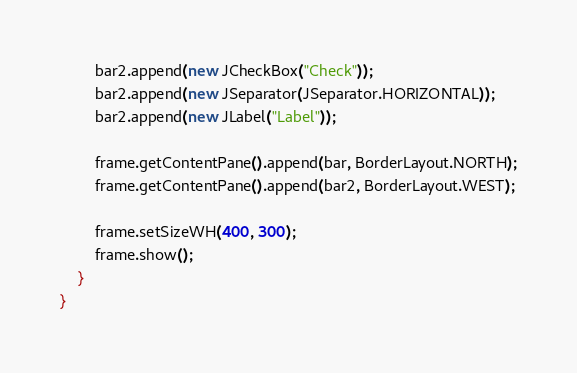<code> <loc_0><loc_0><loc_500><loc_500><_Haxe_>		bar2.append(new JCheckBox("Check"));
		bar2.append(new JSeparator(JSeparator.HORIZONTAL));
		bar2.append(new JLabel("Label"));
		
		frame.getContentPane().append(bar, BorderLayout.NORTH);
		frame.getContentPane().append(bar2, BorderLayout.WEST);
		
		frame.setSizeWH(400, 300);
		frame.show();
	}
}</code> 